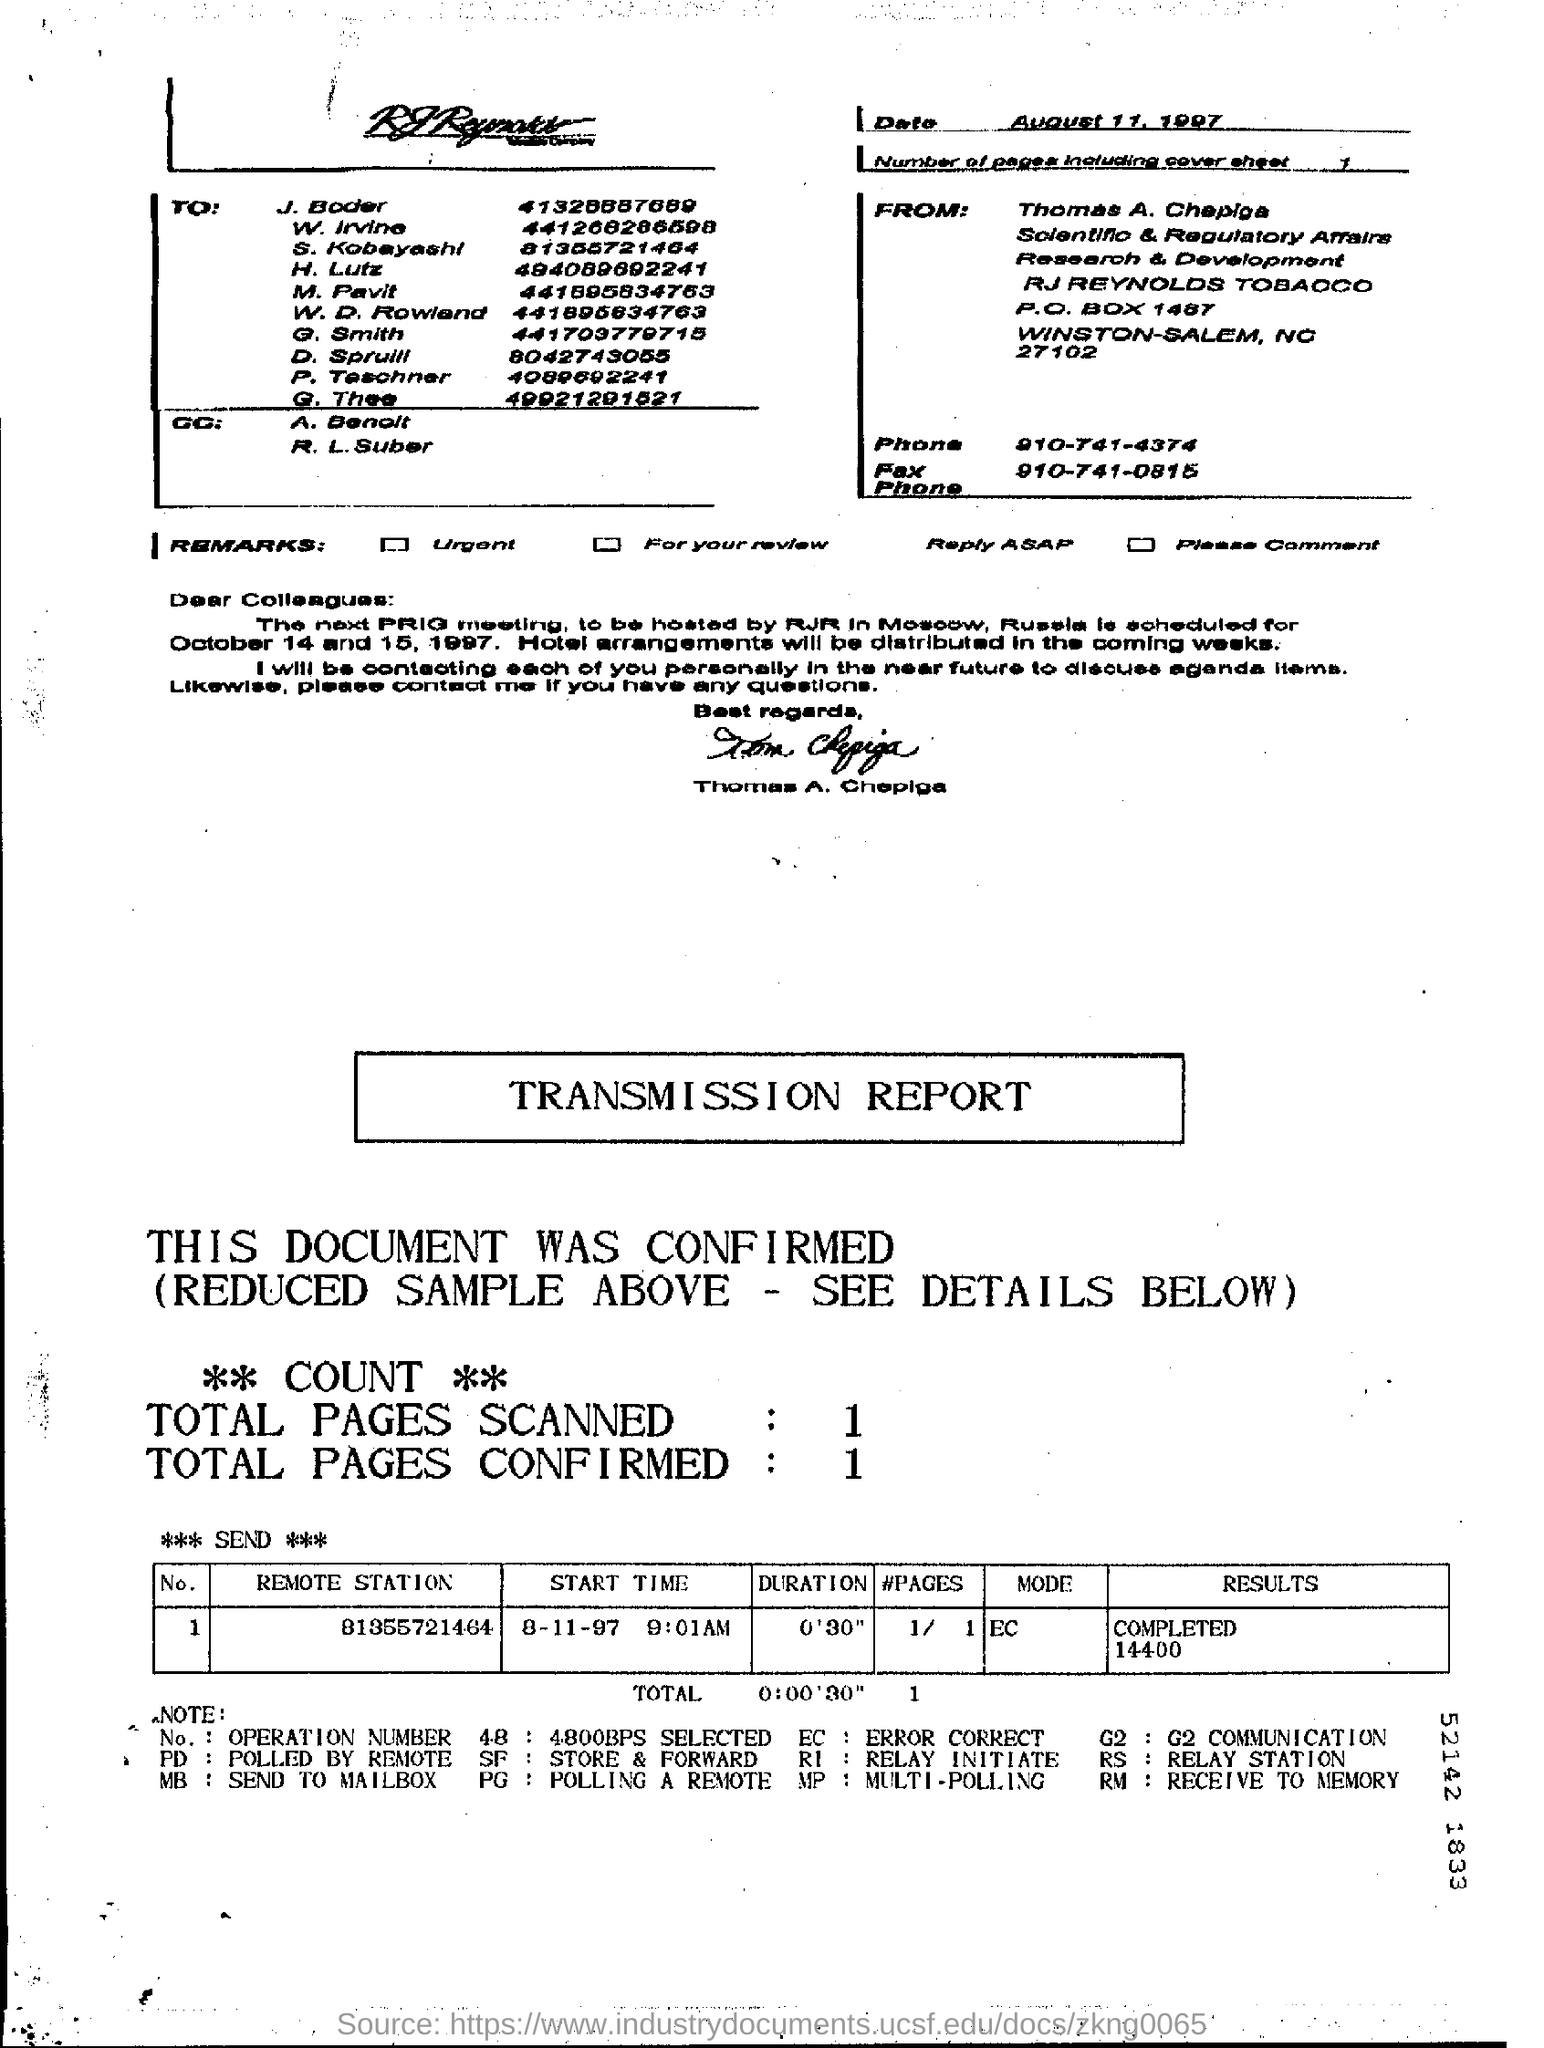Who is the sender of the Fax?
Make the answer very short. Thomas A. Chepiga. What is the Phone No of Thomas A. Chepiga?
Provide a short and direct response. 910-741-4374. How many pages are there in the fax including cover sheet?
Your answer should be compact. 1. 